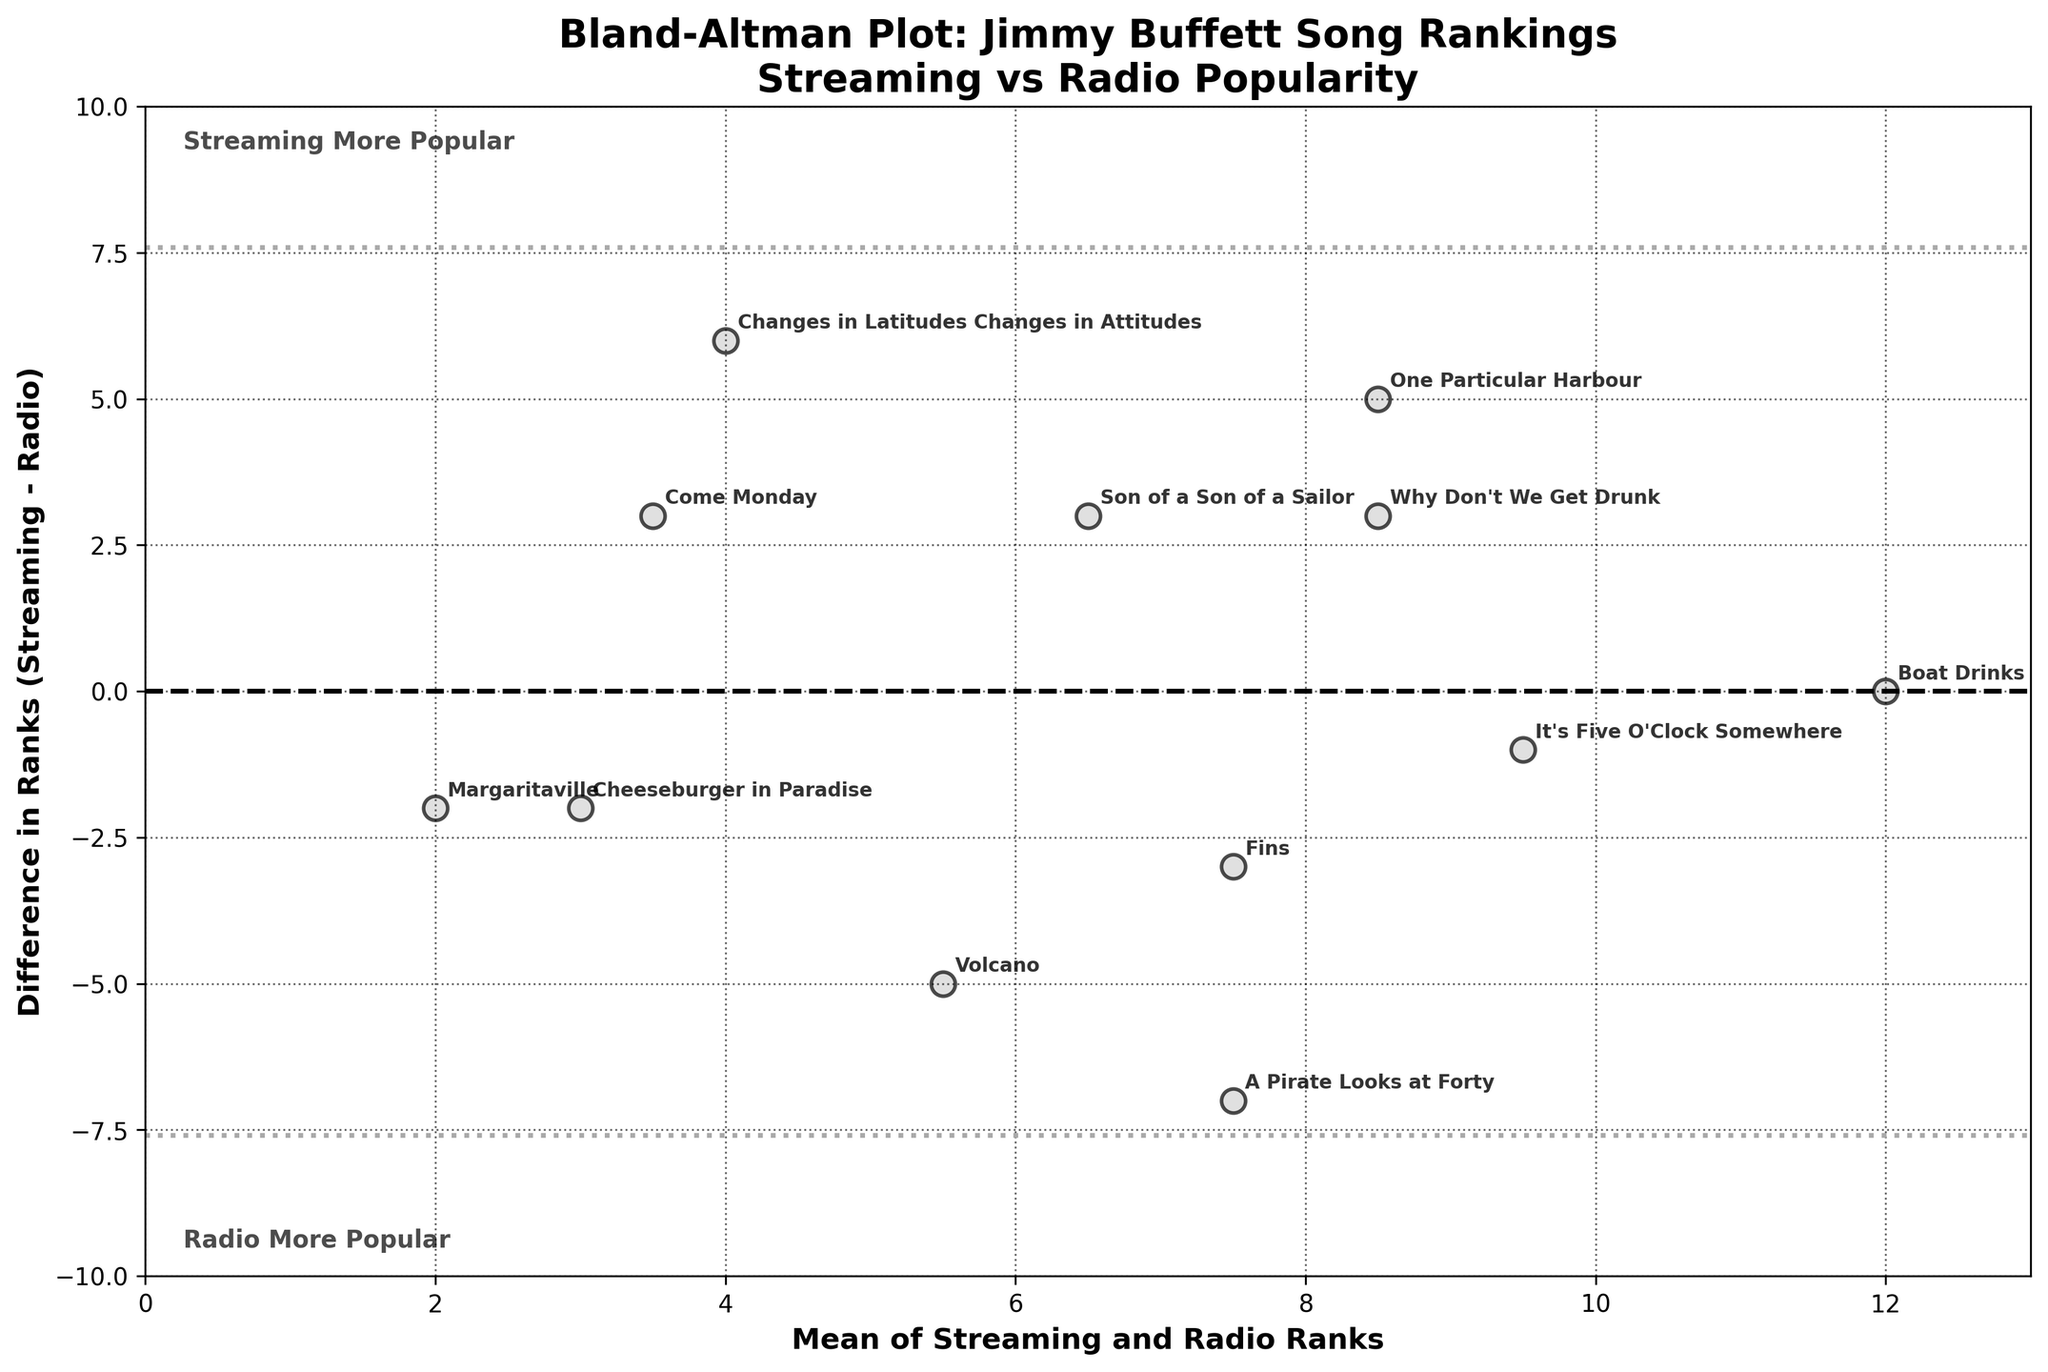What's the title of the plot? The title of the plot is written at the top of the figure. It reads "Bland-Altman Plot: Jimmy Buffett Song Rankings\nStreaming vs Radio Popularity".
Answer: Bland-Altman Plot: Jimmy Buffett Song Rankings\nStreaming vs Radio Popularity What's the difference in rank for the song "A Pirate Looks at Forty"? The difference in rank for "A Pirate Looks at Forty" can be found by looking for its label on the plot. It is indicated by a negative difference, specifically -7.
Answer: -7 Which song has the largest positive rank difference between streaming and radio? "Changes in Latitudes Changes in Attitudes" can be identified as the song with the largest positive rank difference by checking for the data point farthest above the mean line, which is +6.
Answer: Changes in Latitudes Changes in Attitudes What do the dashed and dotted lines represent in the plot? The dashed line indicates the mean difference of ranks (Streaming - Radio), while the dotted lines represent the limits of agreement (mean difference ± 1.96 * standard deviation).
Answer: Mean difference, Limits of agreement What's the range of the x-axis in the plot? The range of the x-axis can be identified by looking at the x-axis limits, which span from 0 to 13.
Answer: 0 to 13 How many songs have a more popular streaming rank compared to radio rank? To find this, count the data points below the mean difference line. These points have negative differences, indicating streaming rank is lower (more popular) than radio rank. There are 7 such songs.
Answer: 7 Which song has an equal rank in both streaming and radio platforms? The data point situated on the horizontal line at rank difference zero represents a song with equal ranks. "Boat Drinks" is at this point.
Answer: Boat Drinks What's the mean rank for "Volcano"? The mean rank for "Volcano" can be identified by finding the corresponding data point. The plot shows "Volcano" at a mean rank of 5.5.
Answer: 5.5 Are there any songs with a rank difference of zero? To answer this, locate the data points that lie exactly on the horizontal line where rank difference equals zero. "Boat Drinks" is the song with a rank difference of zero.
Answer: Yes, Boat Drinks Which song has the most significant deviation in rank between streaming and radio? Finding the furthest point from the mean difference line gives us "A Pirate Looks at Forty," which has the biggest negative difference (-7).
Answer: A Pirate Looks at Forty 